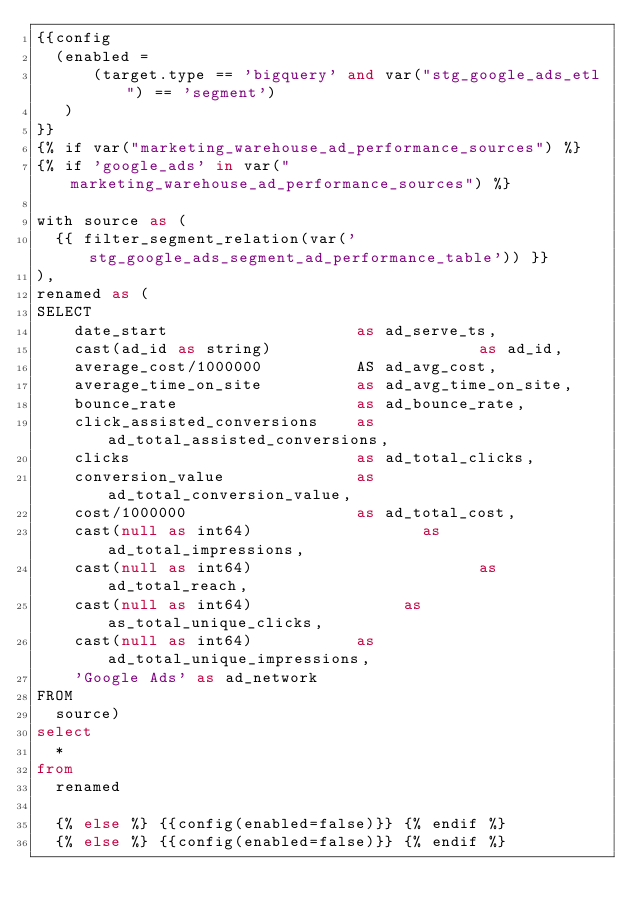<code> <loc_0><loc_0><loc_500><loc_500><_SQL_>{{config
  (enabled =
      (target.type == 'bigquery' and var("stg_google_ads_etl") == 'segment')
   )
}}
{% if var("marketing_warehouse_ad_performance_sources") %}
{% if 'google_ads' in var("marketing_warehouse_ad_performance_sources") %}

with source as (
  {{ filter_segment_relation(var('stg_google_ads_segment_ad_performance_table')) }}
),
renamed as (
SELECT
    date_start                    as ad_serve_ts,
    cast(ad_id as string)                      as ad_id,
    average_cost/1000000          AS ad_avg_cost,
    average_time_on_site          as ad_avg_time_on_site,
    bounce_rate                   as ad_bounce_rate,
    click_assisted_conversions    as ad_total_assisted_conversions,
    clicks                        as ad_total_clicks,
    conversion_value              as ad_total_conversion_value,
    cost/1000000                  as ad_total_cost,
    cast(null as int64)                  as ad_total_impressions,
    cast(null as int64)                        as ad_total_reach,
    cast(null as int64)                as as_total_unique_clicks,
    cast(null as int64)           as ad_total_unique_impressions,
    'Google Ads' as ad_network
FROM
  source)
select
  *
from
  renamed

  {% else %} {{config(enabled=false)}} {% endif %}
  {% else %} {{config(enabled=false)}} {% endif %}
</code> 